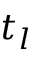<formula> <loc_0><loc_0><loc_500><loc_500>t _ { l }</formula> 